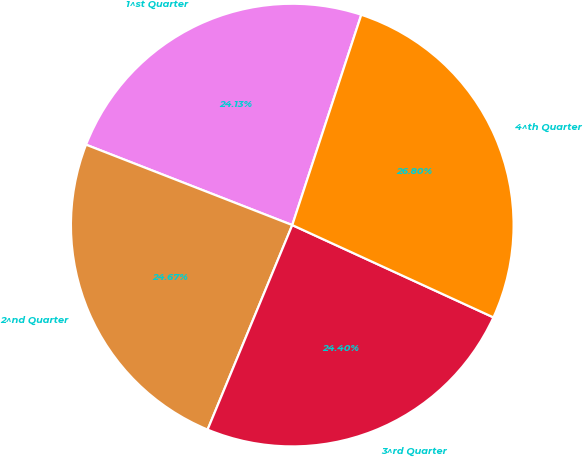Convert chart. <chart><loc_0><loc_0><loc_500><loc_500><pie_chart><fcel>1^st Quarter<fcel>2^nd Quarter<fcel>3^rd Quarter<fcel>4^th Quarter<nl><fcel>24.13%<fcel>24.67%<fcel>24.4%<fcel>26.8%<nl></chart> 